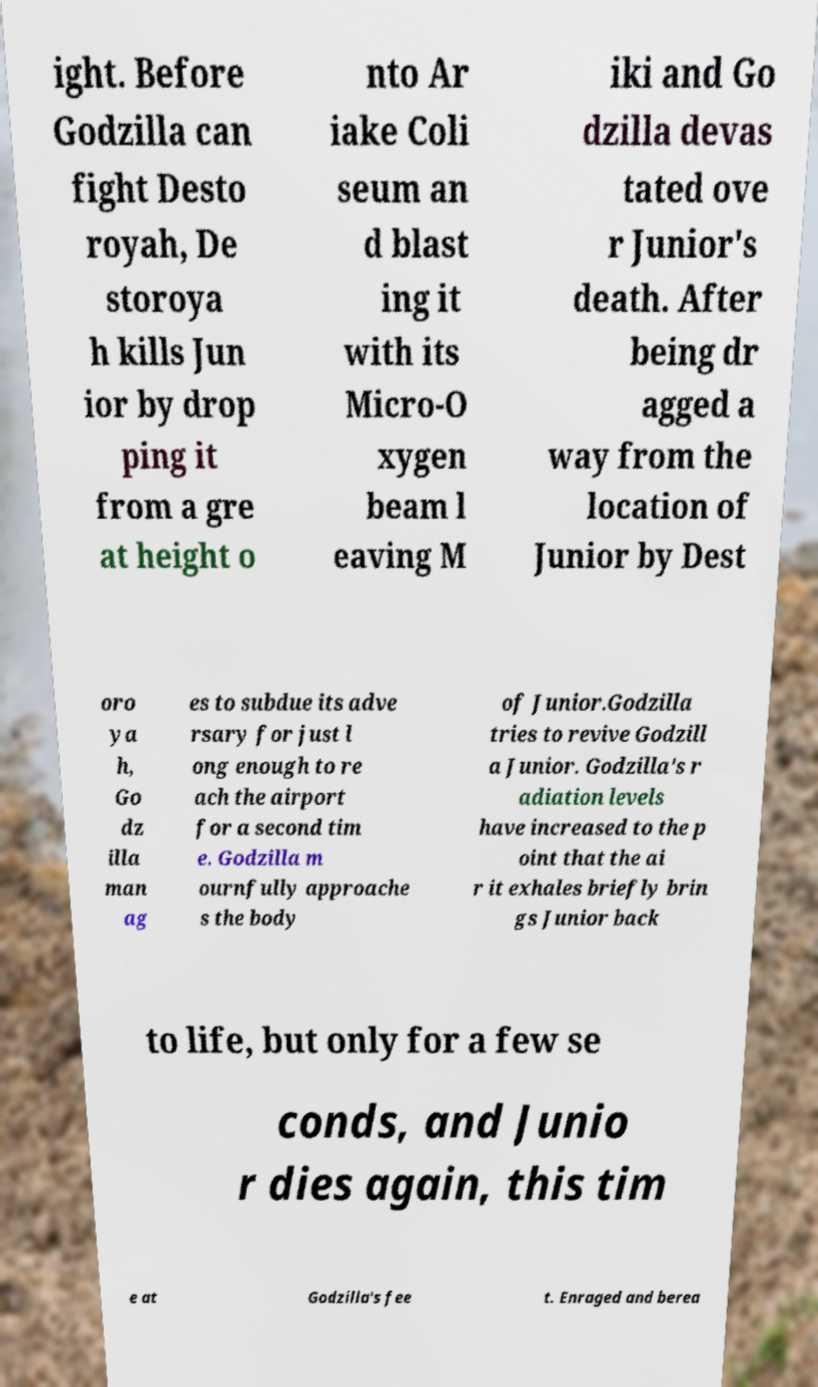There's text embedded in this image that I need extracted. Can you transcribe it verbatim? ight. Before Godzilla can fight Desto royah, De storoya h kills Jun ior by drop ping it from a gre at height o nto Ar iake Coli seum an d blast ing it with its Micro-O xygen beam l eaving M iki and Go dzilla devas tated ove r Junior's death. After being dr agged a way from the location of Junior by Dest oro ya h, Go dz illa man ag es to subdue its adve rsary for just l ong enough to re ach the airport for a second tim e. Godzilla m ournfully approache s the body of Junior.Godzilla tries to revive Godzill a Junior. Godzilla's r adiation levels have increased to the p oint that the ai r it exhales briefly brin gs Junior back to life, but only for a few se conds, and Junio r dies again, this tim e at Godzilla's fee t. Enraged and berea 